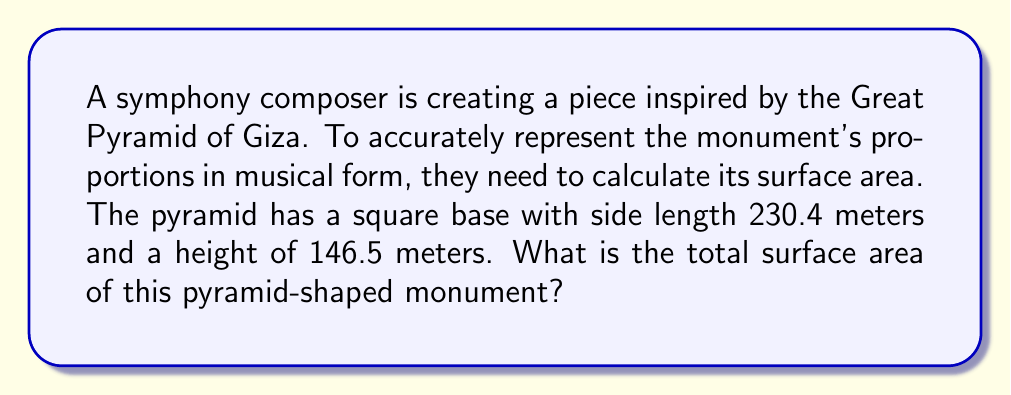Give your solution to this math problem. To find the surface area of a pyramid, we need to calculate the area of the base and the areas of the four triangular faces, then sum them up.

1. Area of the base:
   $$A_{base} = s^2 = 230.4^2 = 53,084.16 \text{ m}^2$$

2. For the triangular faces, we need to find their height (slant height):
   Let $h$ be the pyramid's height and $s$ be the base side length.
   $$\text{slant height} = \sqrt{\left(\frac{s}{2}\right)^2 + h^2}$$
   $$= \sqrt{\left(\frac{230.4}{2}\right)^2 + 146.5^2}$$
   $$= \sqrt{13,225.44 + 21,462.25}$$
   $$= \sqrt{34,687.69} \approx 186.25 \text{ m}$$

3. Area of one triangular face:
   $$A_{face} = \frac{1}{2} \times 230.4 \times 186.25 = 21,450 \text{ m}^2$$

4. Total surface area:
   $$A_{total} = A_{base} + 4 \times A_{face}$$
   $$= 53,084.16 + 4 \times 21,450$$
   $$= 53,084.16 + 85,800$$
   $$= 138,884.16 \text{ m}^2$$

[asy]
import three;

size(200);
currentprojection=perspective(6,3,2);

triple A = (0,0,0), B = (2,0,0), C = (2,2,0), D = (0,2,0), E = (1,1,1.27);

draw(A--B--C--D--cycle);
draw(A--E--C,dashed);
draw(B--E--D);

label("A", A, SW);
label("B", B, SE);
label("C", C, NE);
label("D", D, NW);
label("E", E, N);
[/asy]
Answer: The total surface area of the pyramid-shaped monument is approximately 138,884.16 square meters. 